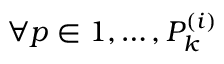Convert formula to latex. <formula><loc_0><loc_0><loc_500><loc_500>\forall p \in 1 , \dots , P _ { k } ^ { ( i ) }</formula> 